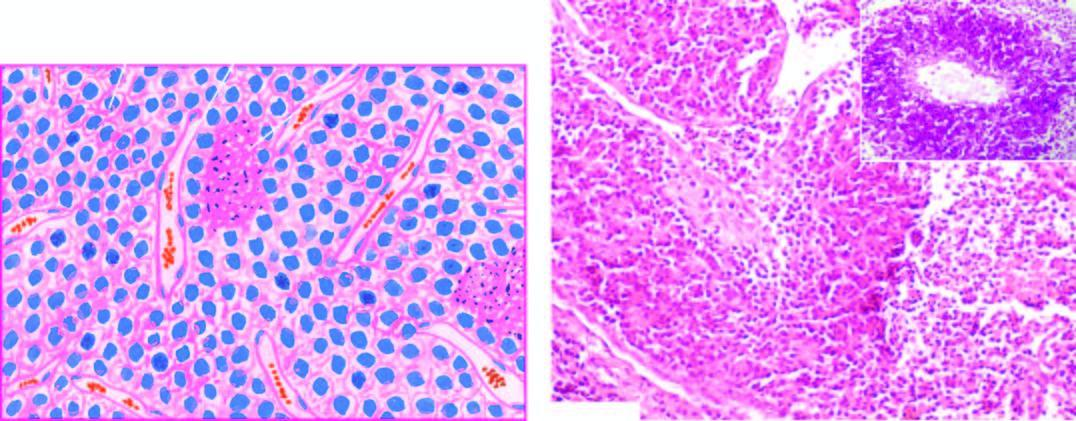does inbox in the right photomicrograph show pas positive tumour cells in perivascular location?
Answer the question using a single word or phrase. Yes 